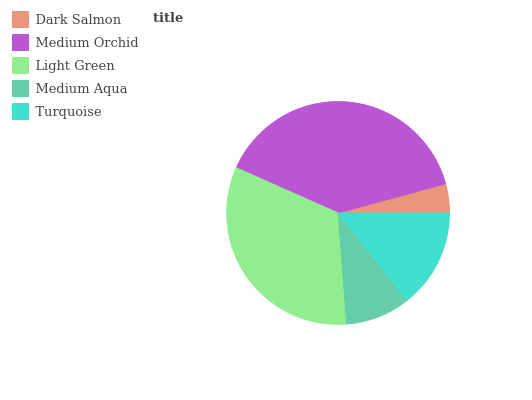Is Dark Salmon the minimum?
Answer yes or no. Yes. Is Medium Orchid the maximum?
Answer yes or no. Yes. Is Light Green the minimum?
Answer yes or no. No. Is Light Green the maximum?
Answer yes or no. No. Is Medium Orchid greater than Light Green?
Answer yes or no. Yes. Is Light Green less than Medium Orchid?
Answer yes or no. Yes. Is Light Green greater than Medium Orchid?
Answer yes or no. No. Is Medium Orchid less than Light Green?
Answer yes or no. No. Is Turquoise the high median?
Answer yes or no. Yes. Is Turquoise the low median?
Answer yes or no. Yes. Is Medium Orchid the high median?
Answer yes or no. No. Is Medium Orchid the low median?
Answer yes or no. No. 